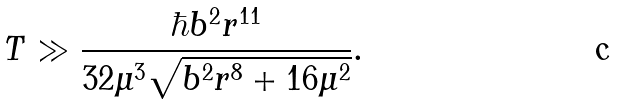Convert formula to latex. <formula><loc_0><loc_0><loc_500><loc_500>T \gg \frac { \hbar { b } ^ { 2 } r ^ { 1 1 } } { 3 2 \mu ^ { 3 } \sqrt { b ^ { 2 } r ^ { 8 } + 1 6 \mu ^ { 2 } } } .</formula> 